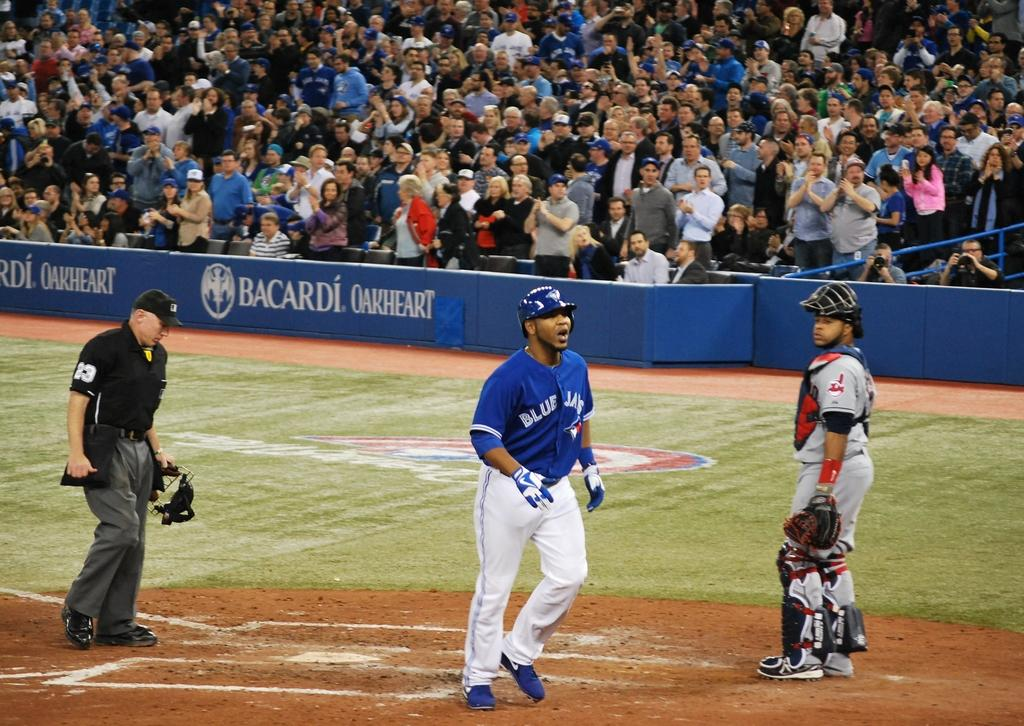<image>
Relay a brief, clear account of the picture shown. A baseball player for the Blue Jays is near a base. 